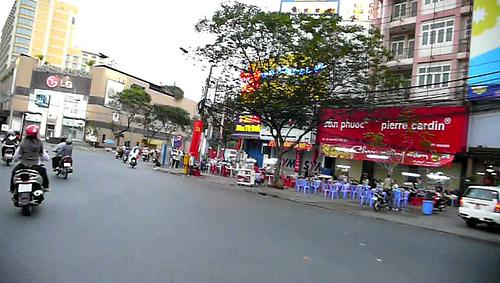Why is the motorcycle rider wearing a red helmet?

Choices:
A) punishment
B) fashion
C) visibility
D) protection protection 